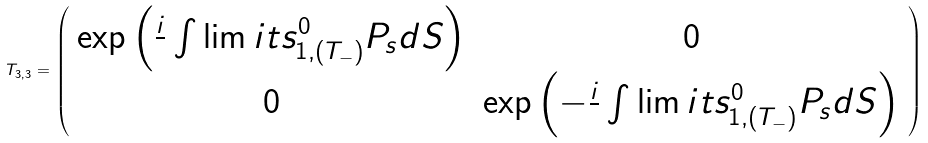<formula> <loc_0><loc_0><loc_500><loc_500>T _ { 3 , 3 } = \left ( \begin{array} { c c } \exp \left ( \frac { i } { } \int \lim i t s _ { 1 , ( T _ { - } ) } ^ { 0 } P _ { s } d S \right ) & 0 \\ 0 & \exp \left ( - \frac { i } { } \int \lim i t s _ { 1 , ( T _ { - } ) } ^ { 0 } P _ { s } d S \right ) \end{array} \right )</formula> 